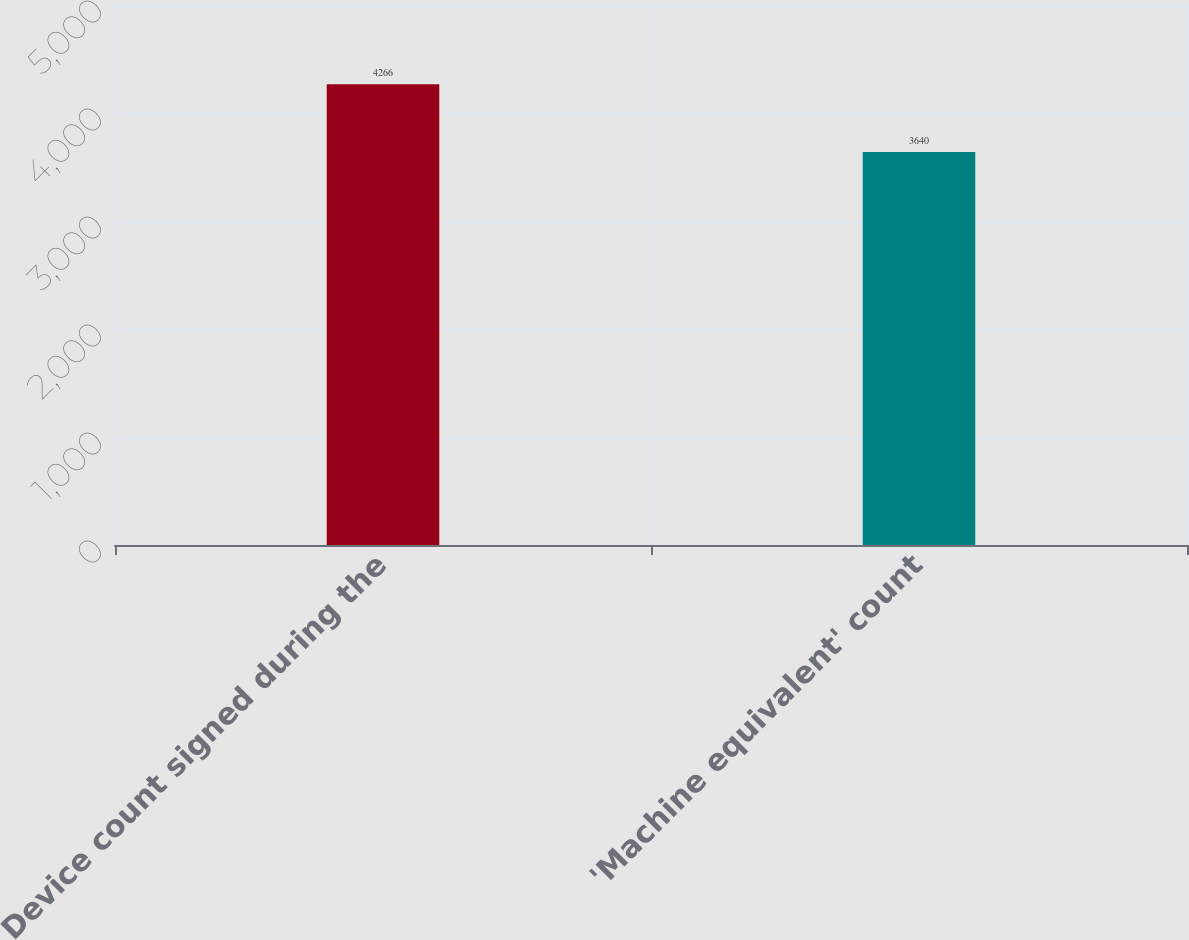<chart> <loc_0><loc_0><loc_500><loc_500><bar_chart><fcel>Device count signed during the<fcel>'Machine equivalent' count<nl><fcel>4266<fcel>3640<nl></chart> 